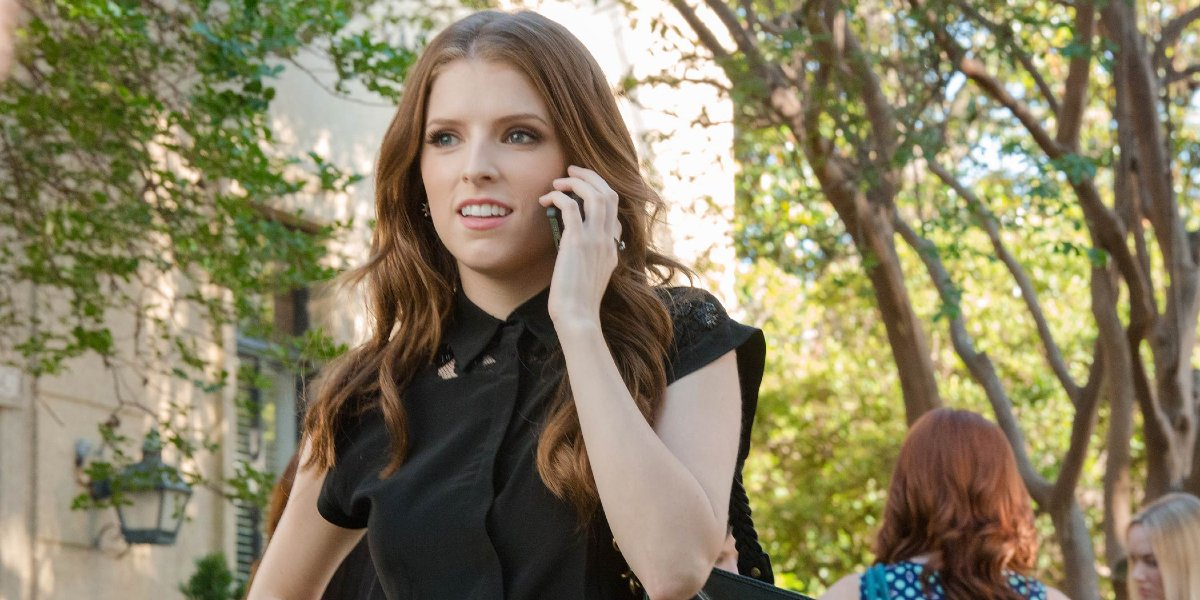How might the time of day impact the mood of this scene? The light and shadows suggest it could be either morning or afternoon. This natural lighting could evoke a sense of a new beginning or the closing of a day, which in turn might influence the mood of the scene to seem hopeful or reflective. 